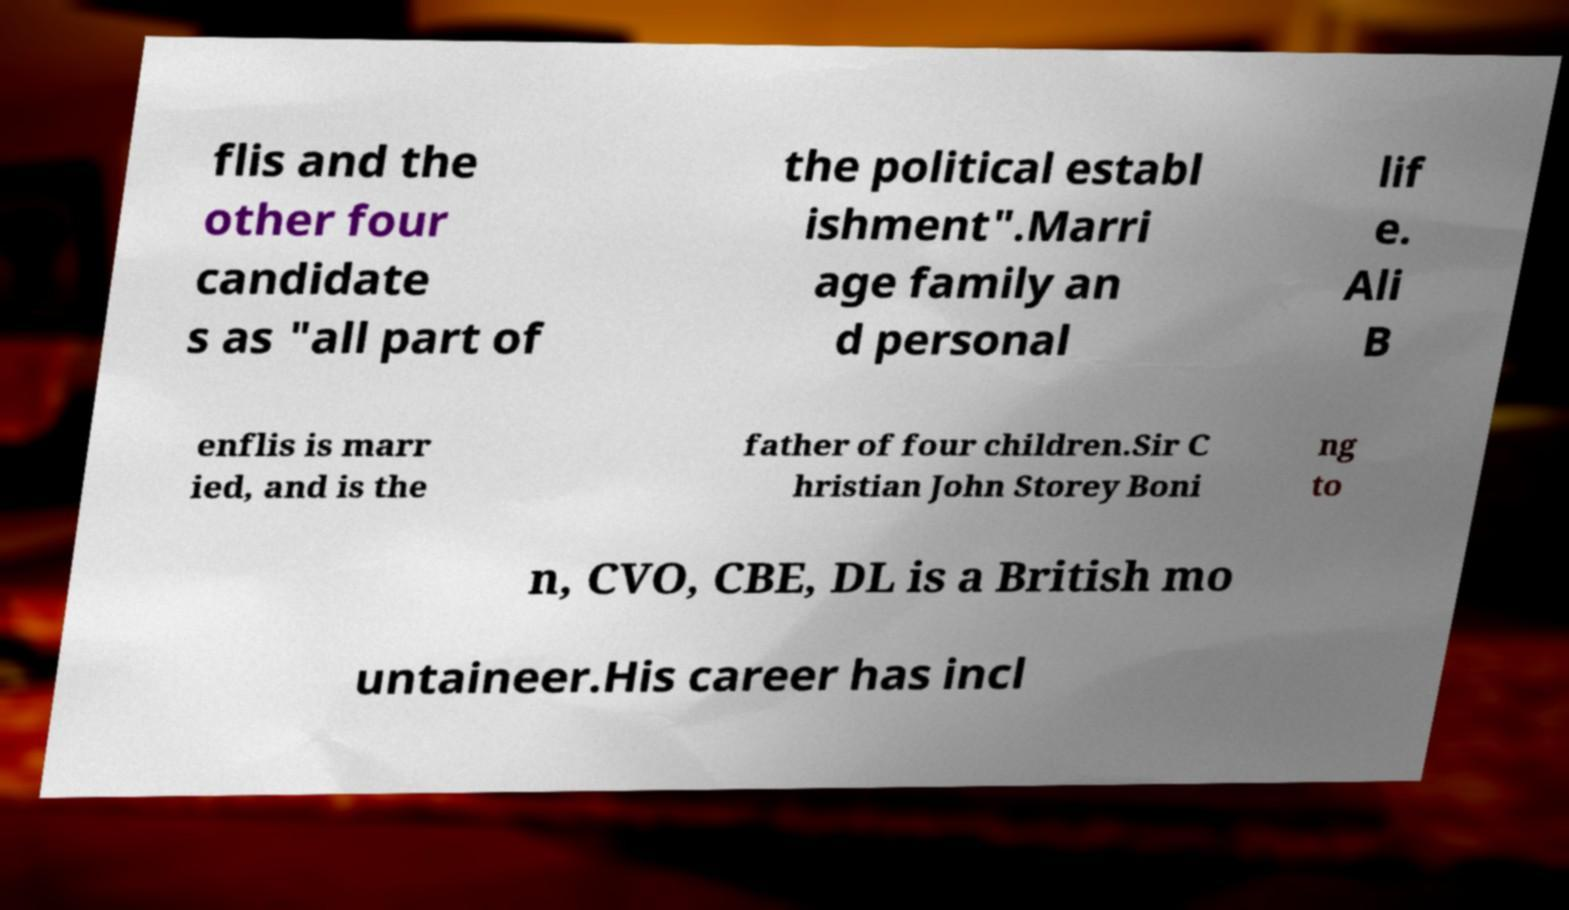Could you extract and type out the text from this image? flis and the other four candidate s as "all part of the political establ ishment".Marri age family an d personal lif e. Ali B enflis is marr ied, and is the father of four children.Sir C hristian John Storey Boni ng to n, CVO, CBE, DL is a British mo untaineer.His career has incl 